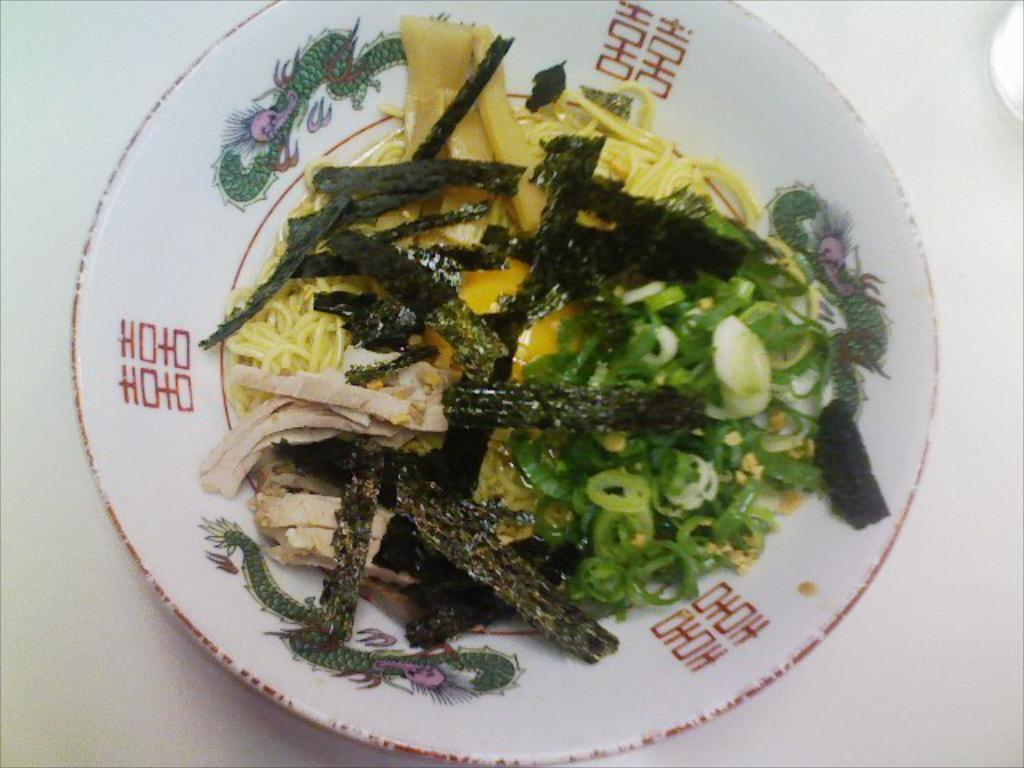What type of food is present in the image? There is a veg salad, noodles, and flour sticks in the image. What is the color of the plate that holds these items? The plate is white. Where is the plate located? The plate is on a table. What type of ring can be seen on the table in the image? There is no ring present on the table in the image. 